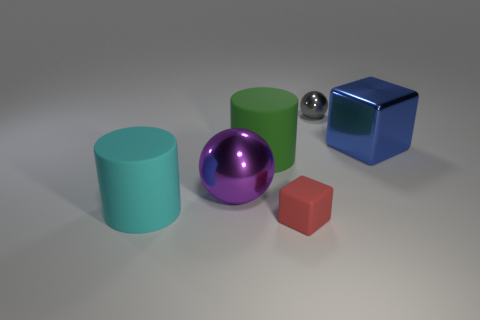Add 2 big gray shiny cubes. How many objects exist? 8 Subtract all cubes. How many objects are left? 4 Subtract all blue shiny cylinders. Subtract all green cylinders. How many objects are left? 5 Add 3 small cubes. How many small cubes are left? 4 Add 5 rubber cylinders. How many rubber cylinders exist? 7 Subtract 0 red balls. How many objects are left? 6 